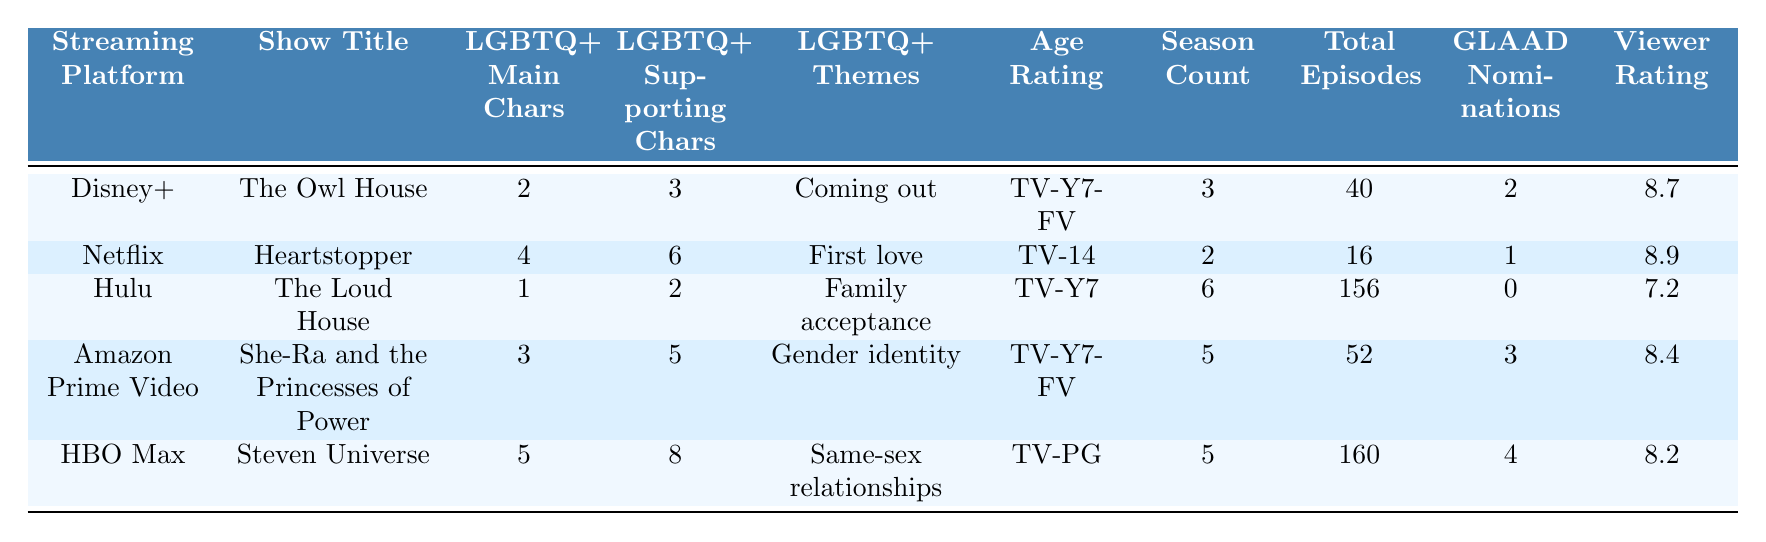What streaming platform has the most LGBTQ+ main characters? HBO Max has 5 LGBTQ+ main characters, which is the highest in the table.
Answer: HBO Max Which show on Disney+ has LGBTQ+ supporting characters? The Owl House on Disney+ has 3 LGBTQ+ supporting characters listed in the table.
Answer: The Owl House How many total episodes are there in The Loud House? The Loud House has a total of 156 episodes according to the table.
Answer: 156 Which show has the highest viewer rating? Heartstopper has the highest viewer rating of 8.9 out of 10.
Answer: 8.9 What is the average number of LGBTQ+ main characters across all shows? The total number of LGBTQ+ main characters is (2 + 4 + 1 + 3 + 5) = 15, and there are 5 shows, so the average is 15/5 = 3.
Answer: 3 Does any show have a GLAAD Media Award nomination? Yes, all shows except The Loud House have at least one GLAAD Media Award nomination.
Answer: Yes Which show has both the highest number of LGBTQ+ main characters and the highest viewer rating? Steven Universe has 5 LGBTQ+ main characters but does not have the highest viewer rating, which is held by Heartstopper. Overall, Heartstopper has the combination of the highest viewer rating and a good number of LGBTQ+ main characters (4).
Answer: Heartstopper Is there a show with LGBTQ+ themes related to "First love"? Yes, Heartstopper deals with the theme of "First love" among its LGBTQ+ themes.
Answer: Yes Which streaming platform offers the most episodes in their LGBTQ+ themed show? Hulu features The Loud House, which has the most episodes at 156.
Answer: Hulu How many shows have more than 5 LGBTQ+ supporting characters? Two shows, Heartstopper (6) and HBO Max (8), have more than 5 LGBTQ+ supporting characters.
Answer: 2 What is the difference in total episodes between The Owl House and She-Ra and the Princesses of Power? The total episodes of The Owl House (40) minus the total episodes of She-Ra (52) equals a difference of 12 episodes.
Answer: 12 